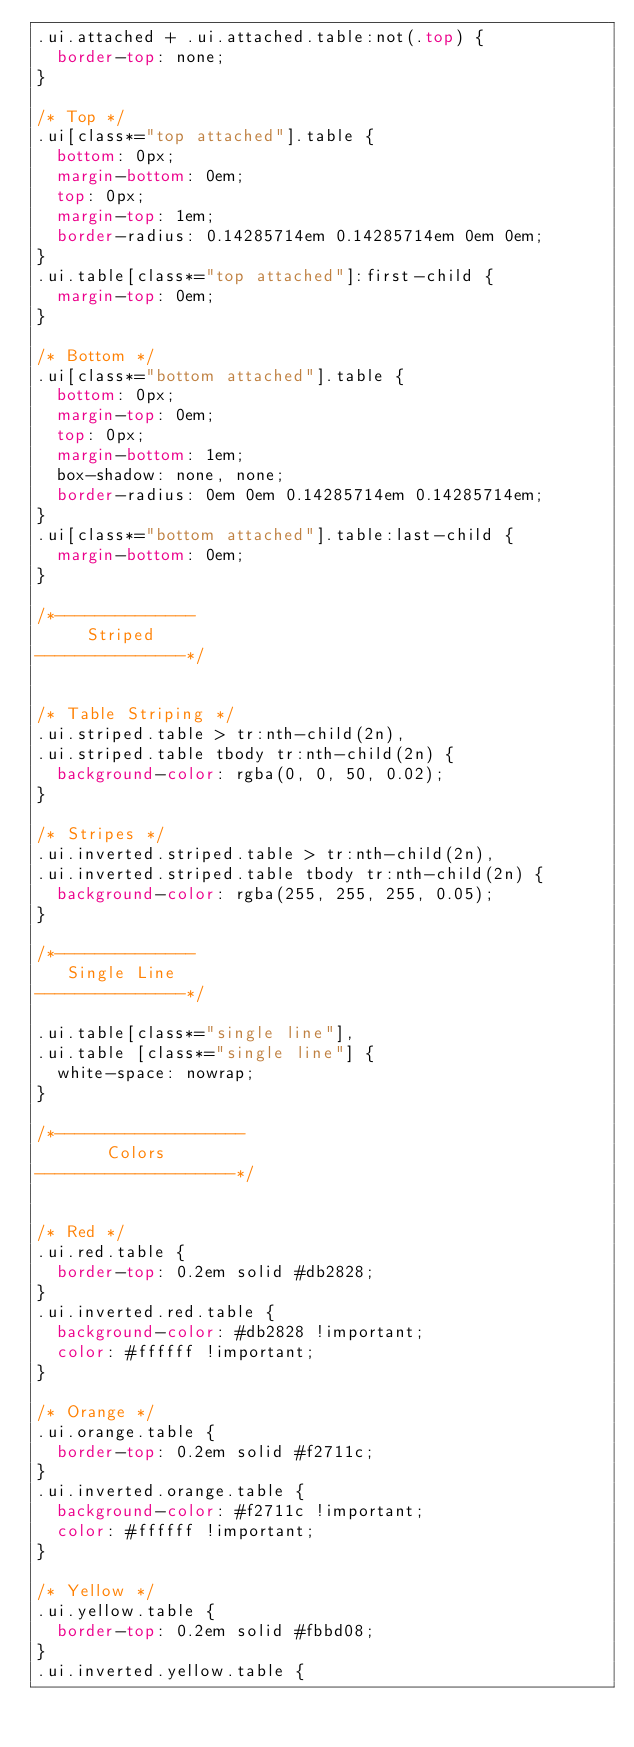Convert code to text. <code><loc_0><loc_0><loc_500><loc_500><_CSS_>.ui.attached + .ui.attached.table:not(.top) {
  border-top: none;
}

/* Top */
.ui[class*="top attached"].table {
  bottom: 0px;
  margin-bottom: 0em;
  top: 0px;
  margin-top: 1em;
  border-radius: 0.14285714em 0.14285714em 0em 0em;
}
.ui.table[class*="top attached"]:first-child {
  margin-top: 0em;
}

/* Bottom */
.ui[class*="bottom attached"].table {
  bottom: 0px;
  margin-top: 0em;
  top: 0px;
  margin-bottom: 1em;
  box-shadow: none, none;
  border-radius: 0em 0em 0.14285714em 0.14285714em;
}
.ui[class*="bottom attached"].table:last-child {
  margin-bottom: 0em;
}

/*--------------
     Striped
---------------*/


/* Table Striping */
.ui.striped.table > tr:nth-child(2n),
.ui.striped.table tbody tr:nth-child(2n) {
  background-color: rgba(0, 0, 50, 0.02);
}

/* Stripes */
.ui.inverted.striped.table > tr:nth-child(2n),
.ui.inverted.striped.table tbody tr:nth-child(2n) {
  background-color: rgba(255, 255, 255, 0.05);
}

/*--------------
   Single Line
---------------*/

.ui.table[class*="single line"],
.ui.table [class*="single line"] {
  white-space: nowrap;
}

/*-------------------
       Colors
--------------------*/


/* Red */
.ui.red.table {
  border-top: 0.2em solid #db2828;
}
.ui.inverted.red.table {
  background-color: #db2828 !important;
  color: #ffffff !important;
}

/* Orange */
.ui.orange.table {
  border-top: 0.2em solid #f2711c;
}
.ui.inverted.orange.table {
  background-color: #f2711c !important;
  color: #ffffff !important;
}

/* Yellow */
.ui.yellow.table {
  border-top: 0.2em solid #fbbd08;
}
.ui.inverted.yellow.table {</code> 